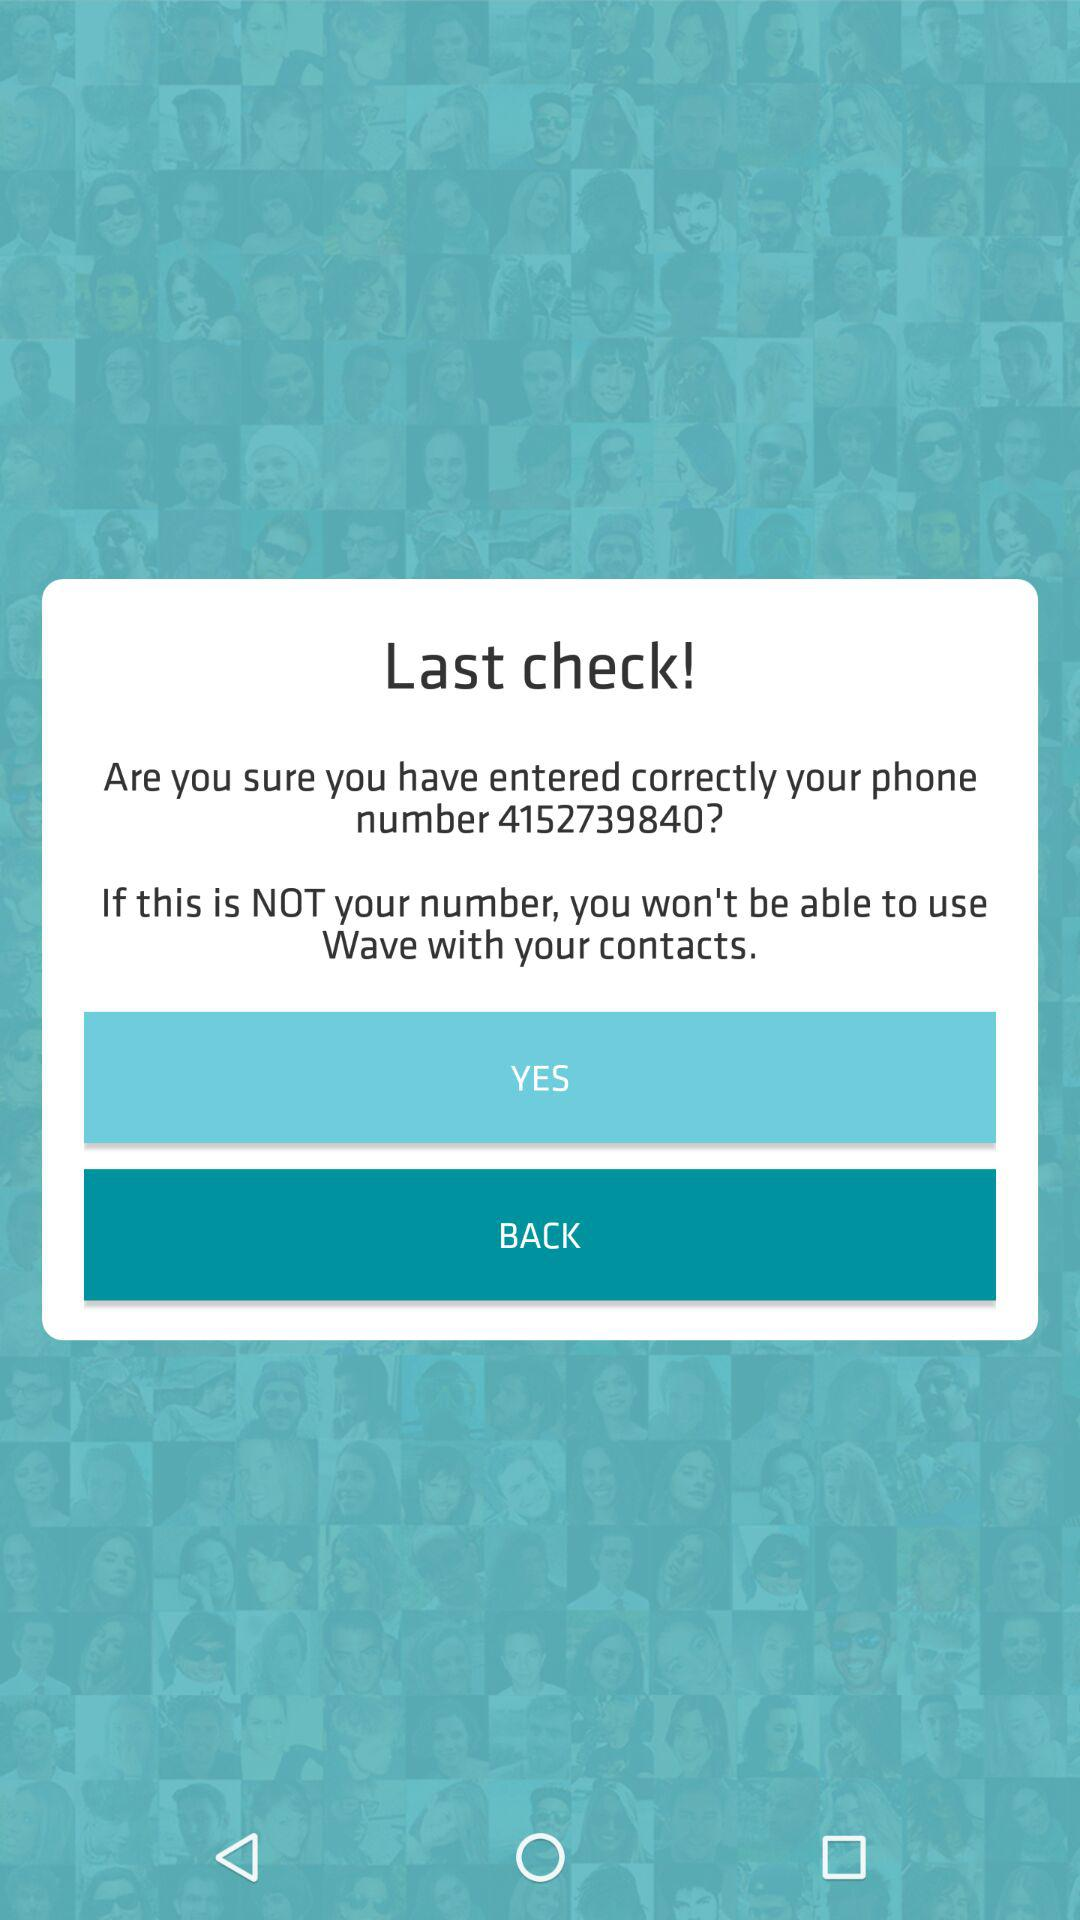What will happen if the entered phone number is not that of the user? If the entered phone number is not that of the user, the user won't be able to use "Wave" with their contacts. 